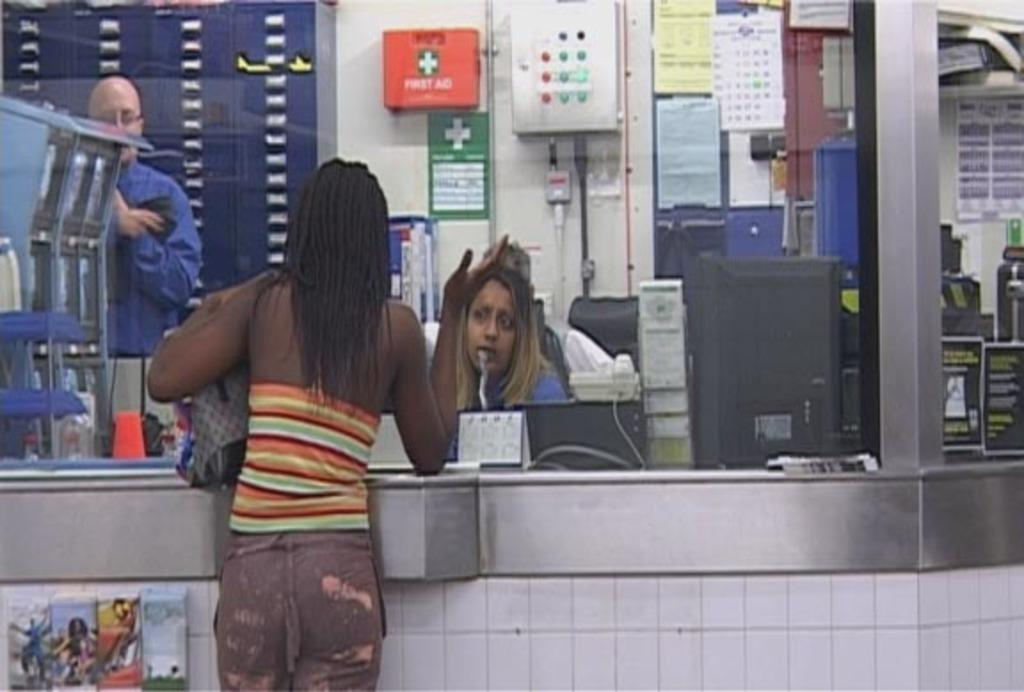How many people are in the image? There are three persons in the image. What type of furniture is present in the image? There is a cabinet in the image. What other objects can be seen in the image? There are machines, boxes, a calendar, and lockers in the image. Where is the image likely taken? The image appears to be taken in a room. What type of grass can be seen growing in the image? There is no grass present in the image; it appears to be taken in an indoor setting. 